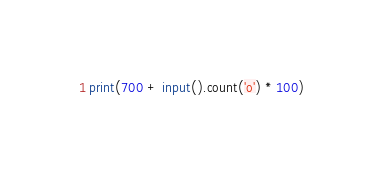Convert code to text. <code><loc_0><loc_0><loc_500><loc_500><_Python_>print(700 + input().count('o') * 100)</code> 